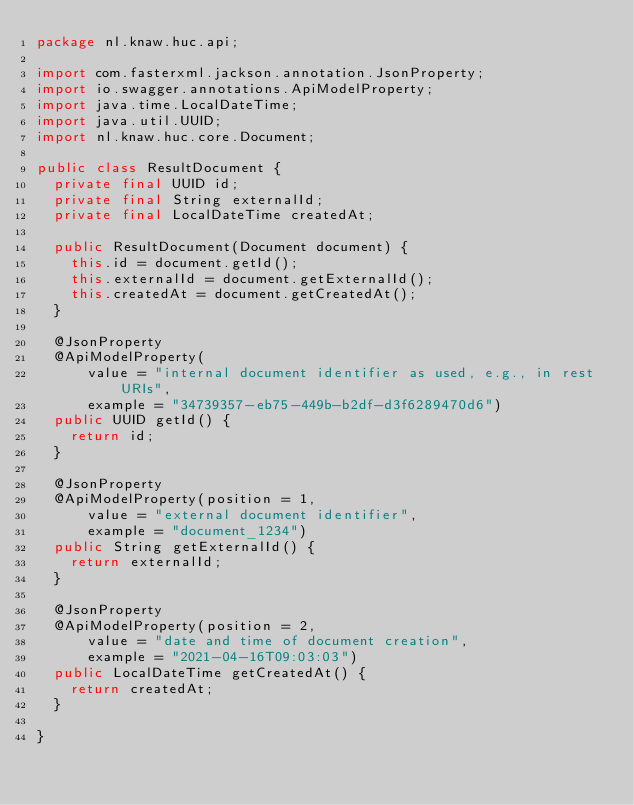<code> <loc_0><loc_0><loc_500><loc_500><_Java_>package nl.knaw.huc.api;

import com.fasterxml.jackson.annotation.JsonProperty;
import io.swagger.annotations.ApiModelProperty;
import java.time.LocalDateTime;
import java.util.UUID;
import nl.knaw.huc.core.Document;

public class ResultDocument {
  private final UUID id;
  private final String externalId;
  private final LocalDateTime createdAt;

  public ResultDocument(Document document) {
    this.id = document.getId();
    this.externalId = document.getExternalId();
    this.createdAt = document.getCreatedAt();
  }

  @JsonProperty
  @ApiModelProperty(
      value = "internal document identifier as used, e.g., in rest URIs",
      example = "34739357-eb75-449b-b2df-d3f6289470d6")
  public UUID getId() {
    return id;
  }

  @JsonProperty
  @ApiModelProperty(position = 1,
      value = "external document identifier",
      example = "document_1234")
  public String getExternalId() {
    return externalId;
  }

  @JsonProperty
  @ApiModelProperty(position = 2,
      value = "date and time of document creation",
      example = "2021-04-16T09:03:03")
  public LocalDateTime getCreatedAt() {
    return createdAt;
  }

}
</code> 